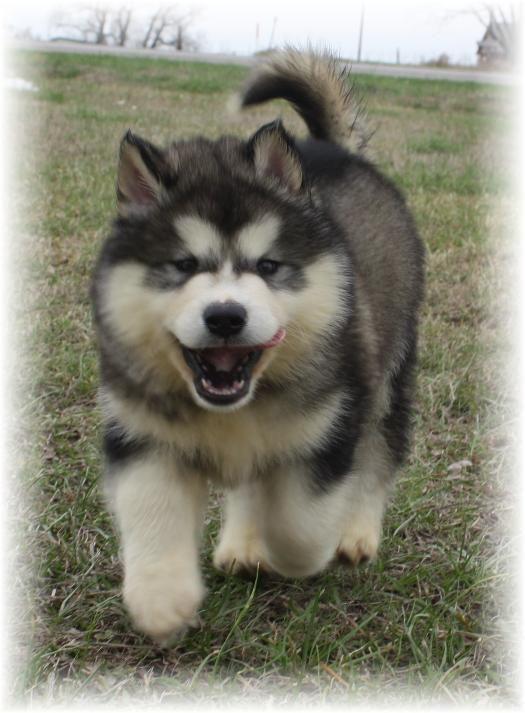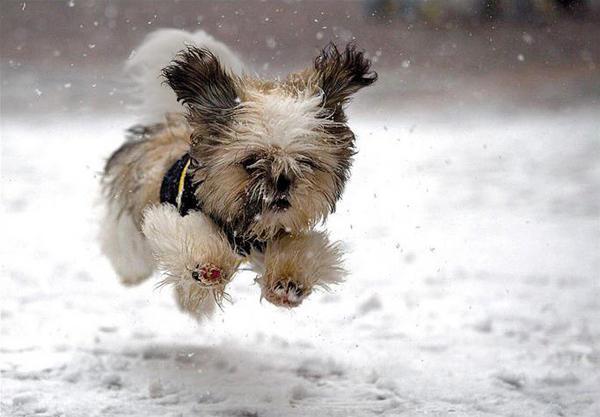The first image is the image on the left, the second image is the image on the right. Assess this claim about the two images: "The combined images show four puppies of the same breed in the snow.". Correct or not? Answer yes or no. No. The first image is the image on the left, the second image is the image on the right. Evaluate the accuracy of this statement regarding the images: "At least one photo shows a single dog facing forward, standing on grass.". Is it true? Answer yes or no. Yes. 